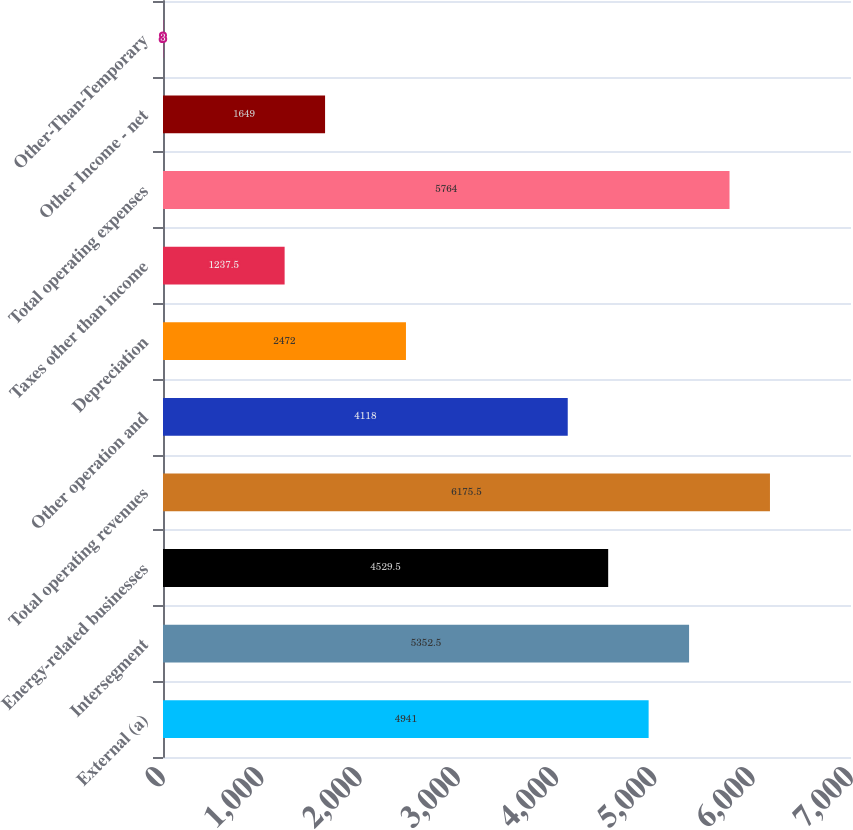Convert chart. <chart><loc_0><loc_0><loc_500><loc_500><bar_chart><fcel>External (a)<fcel>Intersegment<fcel>Energy-related businesses<fcel>Total operating revenues<fcel>Other operation and<fcel>Depreciation<fcel>Taxes other than income<fcel>Total operating expenses<fcel>Other Income - net<fcel>Other-Than-Temporary<nl><fcel>4941<fcel>5352.5<fcel>4529.5<fcel>6175.5<fcel>4118<fcel>2472<fcel>1237.5<fcel>5764<fcel>1649<fcel>3<nl></chart> 